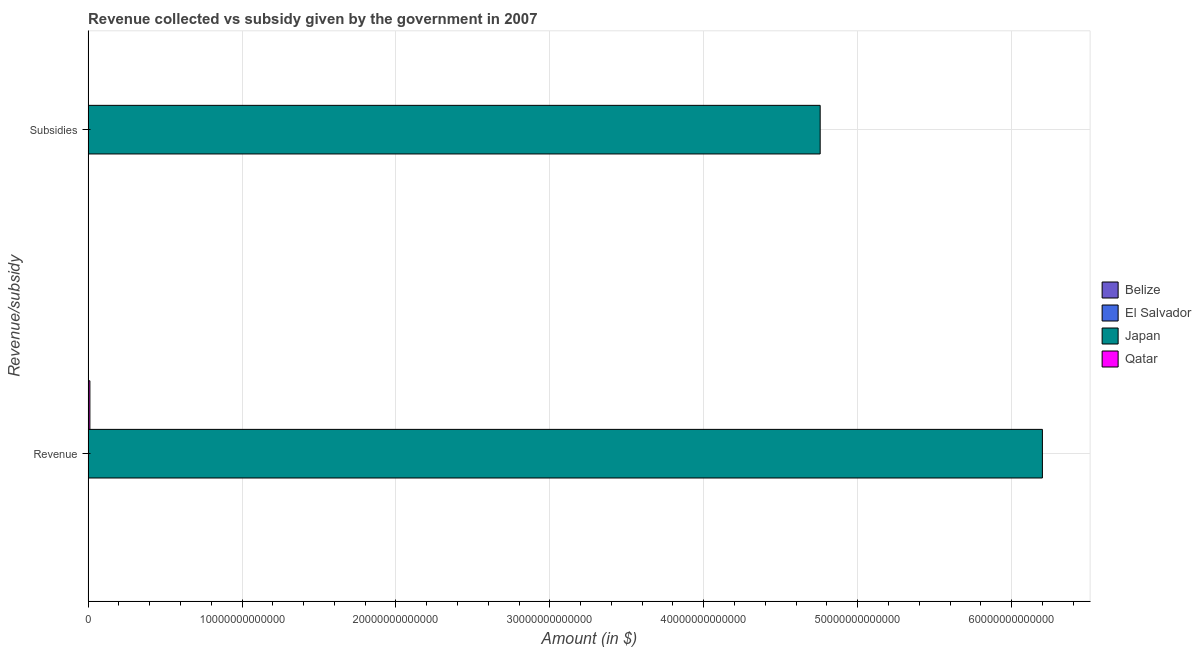How many groups of bars are there?
Make the answer very short. 2. Are the number of bars on each tick of the Y-axis equal?
Offer a very short reply. Yes. How many bars are there on the 2nd tick from the top?
Your answer should be very brief. 4. What is the label of the 2nd group of bars from the top?
Keep it short and to the point. Revenue. What is the amount of revenue collected in Qatar?
Ensure brevity in your answer.  1.18e+11. Across all countries, what is the maximum amount of revenue collected?
Offer a very short reply. 6.20e+13. Across all countries, what is the minimum amount of revenue collected?
Ensure brevity in your answer.  6.75e+08. In which country was the amount of subsidies given maximum?
Give a very brief answer. Japan. In which country was the amount of subsidies given minimum?
Offer a very short reply. Belize. What is the total amount of revenue collected in the graph?
Offer a very short reply. 6.21e+13. What is the difference between the amount of revenue collected in Japan and that in El Salvador?
Your response must be concise. 6.20e+13. What is the difference between the amount of subsidies given in Belize and the amount of revenue collected in Japan?
Your answer should be compact. -6.20e+13. What is the average amount of subsidies given per country?
Keep it short and to the point. 1.19e+13. What is the difference between the amount of revenue collected and amount of subsidies given in Qatar?
Offer a terse response. 1.09e+11. What is the ratio of the amount of revenue collected in Belize to that in Qatar?
Offer a terse response. 0.01. Is the amount of subsidies given in Belize less than that in Japan?
Offer a terse response. Yes. In how many countries, is the amount of revenue collected greater than the average amount of revenue collected taken over all countries?
Ensure brevity in your answer.  1. What does the 3rd bar from the top in Revenue represents?
Provide a short and direct response. El Salvador. What does the 1st bar from the bottom in Subsidies represents?
Offer a very short reply. Belize. How many countries are there in the graph?
Ensure brevity in your answer.  4. What is the difference between two consecutive major ticks on the X-axis?
Keep it short and to the point. 1.00e+13. Are the values on the major ticks of X-axis written in scientific E-notation?
Give a very brief answer. No. Where does the legend appear in the graph?
Give a very brief answer. Center right. What is the title of the graph?
Your answer should be compact. Revenue collected vs subsidy given by the government in 2007. What is the label or title of the X-axis?
Keep it short and to the point. Amount (in $). What is the label or title of the Y-axis?
Provide a succinct answer. Revenue/subsidy. What is the Amount (in $) in Belize in Revenue?
Provide a short and direct response. 6.75e+08. What is the Amount (in $) of El Salvador in Revenue?
Give a very brief answer. 3.90e+09. What is the Amount (in $) of Japan in Revenue?
Provide a short and direct response. 6.20e+13. What is the Amount (in $) in Qatar in Revenue?
Make the answer very short. 1.18e+11. What is the Amount (in $) of Belize in Subsidies?
Your response must be concise. 1.18e+08. What is the Amount (in $) in El Salvador in Subsidies?
Provide a succinct answer. 7.31e+08. What is the Amount (in $) in Japan in Subsidies?
Your response must be concise. 4.76e+13. What is the Amount (in $) in Qatar in Subsidies?
Offer a terse response. 8.92e+09. Across all Revenue/subsidy, what is the maximum Amount (in $) of Belize?
Your answer should be compact. 6.75e+08. Across all Revenue/subsidy, what is the maximum Amount (in $) in El Salvador?
Keep it short and to the point. 3.90e+09. Across all Revenue/subsidy, what is the maximum Amount (in $) of Japan?
Your answer should be compact. 6.20e+13. Across all Revenue/subsidy, what is the maximum Amount (in $) of Qatar?
Your answer should be very brief. 1.18e+11. Across all Revenue/subsidy, what is the minimum Amount (in $) of Belize?
Make the answer very short. 1.18e+08. Across all Revenue/subsidy, what is the minimum Amount (in $) of El Salvador?
Make the answer very short. 7.31e+08. Across all Revenue/subsidy, what is the minimum Amount (in $) in Japan?
Make the answer very short. 4.76e+13. Across all Revenue/subsidy, what is the minimum Amount (in $) of Qatar?
Your answer should be compact. 8.92e+09. What is the total Amount (in $) in Belize in the graph?
Offer a terse response. 7.93e+08. What is the total Amount (in $) of El Salvador in the graph?
Give a very brief answer. 4.63e+09. What is the total Amount (in $) in Japan in the graph?
Your response must be concise. 1.10e+14. What is the total Amount (in $) of Qatar in the graph?
Offer a very short reply. 1.26e+11. What is the difference between the Amount (in $) in Belize in Revenue and that in Subsidies?
Provide a succinct answer. 5.57e+08. What is the difference between the Amount (in $) of El Salvador in Revenue and that in Subsidies?
Provide a succinct answer. 3.17e+09. What is the difference between the Amount (in $) of Japan in Revenue and that in Subsidies?
Your response must be concise. 1.44e+13. What is the difference between the Amount (in $) in Qatar in Revenue and that in Subsidies?
Give a very brief answer. 1.09e+11. What is the difference between the Amount (in $) in Belize in Revenue and the Amount (in $) in El Salvador in Subsidies?
Offer a very short reply. -5.59e+07. What is the difference between the Amount (in $) in Belize in Revenue and the Amount (in $) in Japan in Subsidies?
Keep it short and to the point. -4.76e+13. What is the difference between the Amount (in $) of Belize in Revenue and the Amount (in $) of Qatar in Subsidies?
Offer a very short reply. -8.24e+09. What is the difference between the Amount (in $) in El Salvador in Revenue and the Amount (in $) in Japan in Subsidies?
Ensure brevity in your answer.  -4.76e+13. What is the difference between the Amount (in $) in El Salvador in Revenue and the Amount (in $) in Qatar in Subsidies?
Your answer should be compact. -5.02e+09. What is the difference between the Amount (in $) in Japan in Revenue and the Amount (in $) in Qatar in Subsidies?
Your answer should be very brief. 6.20e+13. What is the average Amount (in $) in Belize per Revenue/subsidy?
Make the answer very short. 3.97e+08. What is the average Amount (in $) in El Salvador per Revenue/subsidy?
Your answer should be very brief. 2.32e+09. What is the average Amount (in $) in Japan per Revenue/subsidy?
Give a very brief answer. 5.48e+13. What is the average Amount (in $) in Qatar per Revenue/subsidy?
Your answer should be very brief. 6.32e+1. What is the difference between the Amount (in $) in Belize and Amount (in $) in El Salvador in Revenue?
Keep it short and to the point. -3.23e+09. What is the difference between the Amount (in $) in Belize and Amount (in $) in Japan in Revenue?
Provide a short and direct response. -6.20e+13. What is the difference between the Amount (in $) in Belize and Amount (in $) in Qatar in Revenue?
Keep it short and to the point. -1.17e+11. What is the difference between the Amount (in $) of El Salvador and Amount (in $) of Japan in Revenue?
Give a very brief answer. -6.20e+13. What is the difference between the Amount (in $) of El Salvador and Amount (in $) of Qatar in Revenue?
Keep it short and to the point. -1.14e+11. What is the difference between the Amount (in $) of Japan and Amount (in $) of Qatar in Revenue?
Offer a terse response. 6.19e+13. What is the difference between the Amount (in $) of Belize and Amount (in $) of El Salvador in Subsidies?
Keep it short and to the point. -6.13e+08. What is the difference between the Amount (in $) in Belize and Amount (in $) in Japan in Subsidies?
Keep it short and to the point. -4.76e+13. What is the difference between the Amount (in $) in Belize and Amount (in $) in Qatar in Subsidies?
Offer a terse response. -8.80e+09. What is the difference between the Amount (in $) in El Salvador and Amount (in $) in Japan in Subsidies?
Offer a terse response. -4.76e+13. What is the difference between the Amount (in $) of El Salvador and Amount (in $) of Qatar in Subsidies?
Offer a terse response. -8.19e+09. What is the difference between the Amount (in $) in Japan and Amount (in $) in Qatar in Subsidies?
Your response must be concise. 4.76e+13. What is the ratio of the Amount (in $) of Belize in Revenue to that in Subsidies?
Provide a short and direct response. 5.72. What is the ratio of the Amount (in $) in El Salvador in Revenue to that in Subsidies?
Provide a succinct answer. 5.34. What is the ratio of the Amount (in $) of Japan in Revenue to that in Subsidies?
Make the answer very short. 1.3. What is the ratio of the Amount (in $) of Qatar in Revenue to that in Subsidies?
Provide a short and direct response. 13.18. What is the difference between the highest and the second highest Amount (in $) of Belize?
Provide a succinct answer. 5.57e+08. What is the difference between the highest and the second highest Amount (in $) of El Salvador?
Provide a short and direct response. 3.17e+09. What is the difference between the highest and the second highest Amount (in $) of Japan?
Provide a succinct answer. 1.44e+13. What is the difference between the highest and the second highest Amount (in $) in Qatar?
Provide a succinct answer. 1.09e+11. What is the difference between the highest and the lowest Amount (in $) of Belize?
Keep it short and to the point. 5.57e+08. What is the difference between the highest and the lowest Amount (in $) of El Salvador?
Your answer should be compact. 3.17e+09. What is the difference between the highest and the lowest Amount (in $) in Japan?
Offer a very short reply. 1.44e+13. What is the difference between the highest and the lowest Amount (in $) in Qatar?
Your answer should be compact. 1.09e+11. 